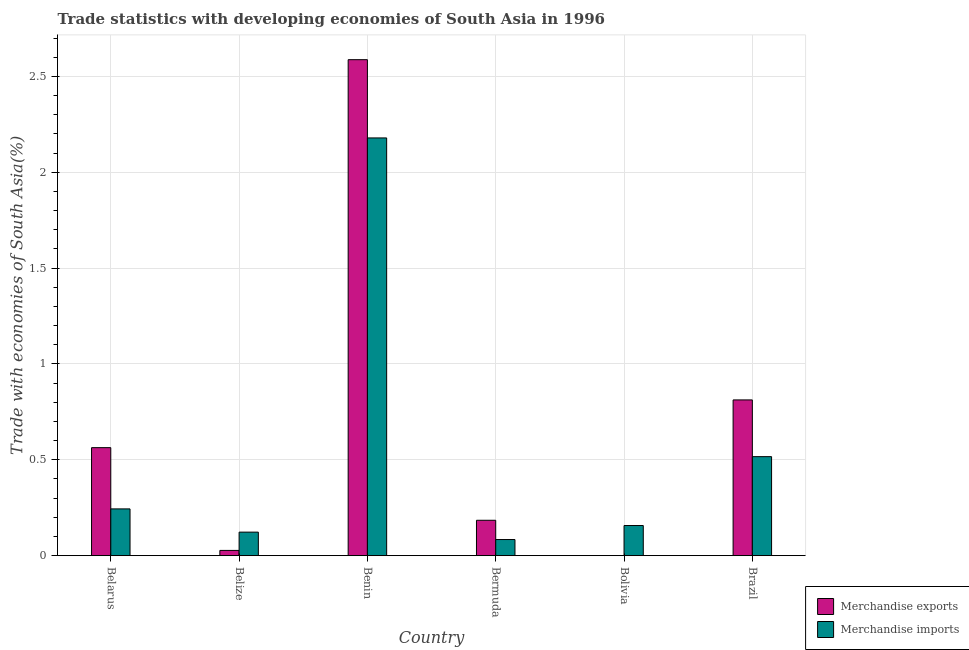How many groups of bars are there?
Your response must be concise. 6. How many bars are there on the 5th tick from the right?
Offer a terse response. 2. What is the label of the 4th group of bars from the left?
Provide a short and direct response. Bermuda. What is the merchandise exports in Bermuda?
Keep it short and to the point. 0.18. Across all countries, what is the maximum merchandise imports?
Offer a terse response. 2.18. Across all countries, what is the minimum merchandise imports?
Your response must be concise. 0.08. In which country was the merchandise exports maximum?
Ensure brevity in your answer.  Benin. In which country was the merchandise imports minimum?
Provide a succinct answer. Bermuda. What is the total merchandise imports in the graph?
Provide a succinct answer. 3.3. What is the difference between the merchandise exports in Benin and that in Brazil?
Provide a short and direct response. 1.78. What is the difference between the merchandise imports in Bolivia and the merchandise exports in Brazil?
Keep it short and to the point. -0.66. What is the average merchandise imports per country?
Make the answer very short. 0.55. What is the difference between the merchandise imports and merchandise exports in Bolivia?
Offer a terse response. 0.16. In how many countries, is the merchandise imports greater than 2.2 %?
Provide a short and direct response. 0. What is the ratio of the merchandise imports in Bermuda to that in Brazil?
Offer a very short reply. 0.16. What is the difference between the highest and the second highest merchandise imports?
Give a very brief answer. 1.66. What is the difference between the highest and the lowest merchandise imports?
Keep it short and to the point. 2.1. What does the 1st bar from the left in Belarus represents?
Your answer should be compact. Merchandise exports. What does the 2nd bar from the right in Brazil represents?
Give a very brief answer. Merchandise exports. Are all the bars in the graph horizontal?
Offer a terse response. No. How many countries are there in the graph?
Offer a terse response. 6. Does the graph contain any zero values?
Ensure brevity in your answer.  No. Where does the legend appear in the graph?
Offer a very short reply. Bottom right. What is the title of the graph?
Your answer should be very brief. Trade statistics with developing economies of South Asia in 1996. Does "Arms imports" appear as one of the legend labels in the graph?
Your answer should be very brief. No. What is the label or title of the X-axis?
Offer a terse response. Country. What is the label or title of the Y-axis?
Make the answer very short. Trade with economies of South Asia(%). What is the Trade with economies of South Asia(%) in Merchandise exports in Belarus?
Provide a succinct answer. 0.56. What is the Trade with economies of South Asia(%) in Merchandise imports in Belarus?
Provide a succinct answer. 0.24. What is the Trade with economies of South Asia(%) in Merchandise exports in Belize?
Keep it short and to the point. 0.03. What is the Trade with economies of South Asia(%) of Merchandise imports in Belize?
Your response must be concise. 0.12. What is the Trade with economies of South Asia(%) of Merchandise exports in Benin?
Provide a short and direct response. 2.59. What is the Trade with economies of South Asia(%) of Merchandise imports in Benin?
Give a very brief answer. 2.18. What is the Trade with economies of South Asia(%) of Merchandise exports in Bermuda?
Provide a short and direct response. 0.18. What is the Trade with economies of South Asia(%) in Merchandise imports in Bermuda?
Make the answer very short. 0.08. What is the Trade with economies of South Asia(%) of Merchandise exports in Bolivia?
Provide a succinct answer. 0. What is the Trade with economies of South Asia(%) in Merchandise imports in Bolivia?
Your answer should be compact. 0.16. What is the Trade with economies of South Asia(%) in Merchandise exports in Brazil?
Offer a terse response. 0.81. What is the Trade with economies of South Asia(%) in Merchandise imports in Brazil?
Offer a terse response. 0.52. Across all countries, what is the maximum Trade with economies of South Asia(%) in Merchandise exports?
Your response must be concise. 2.59. Across all countries, what is the maximum Trade with economies of South Asia(%) in Merchandise imports?
Offer a terse response. 2.18. Across all countries, what is the minimum Trade with economies of South Asia(%) of Merchandise exports?
Your answer should be very brief. 0. Across all countries, what is the minimum Trade with economies of South Asia(%) of Merchandise imports?
Ensure brevity in your answer.  0.08. What is the total Trade with economies of South Asia(%) in Merchandise exports in the graph?
Ensure brevity in your answer.  4.18. What is the total Trade with economies of South Asia(%) in Merchandise imports in the graph?
Offer a very short reply. 3.3. What is the difference between the Trade with economies of South Asia(%) in Merchandise exports in Belarus and that in Belize?
Give a very brief answer. 0.54. What is the difference between the Trade with economies of South Asia(%) of Merchandise imports in Belarus and that in Belize?
Your answer should be compact. 0.12. What is the difference between the Trade with economies of South Asia(%) of Merchandise exports in Belarus and that in Benin?
Your answer should be compact. -2.02. What is the difference between the Trade with economies of South Asia(%) of Merchandise imports in Belarus and that in Benin?
Keep it short and to the point. -1.94. What is the difference between the Trade with economies of South Asia(%) in Merchandise exports in Belarus and that in Bermuda?
Your answer should be compact. 0.38. What is the difference between the Trade with economies of South Asia(%) in Merchandise imports in Belarus and that in Bermuda?
Give a very brief answer. 0.16. What is the difference between the Trade with economies of South Asia(%) in Merchandise exports in Belarus and that in Bolivia?
Your answer should be compact. 0.56. What is the difference between the Trade with economies of South Asia(%) in Merchandise imports in Belarus and that in Bolivia?
Your answer should be compact. 0.09. What is the difference between the Trade with economies of South Asia(%) of Merchandise exports in Belarus and that in Brazil?
Ensure brevity in your answer.  -0.25. What is the difference between the Trade with economies of South Asia(%) of Merchandise imports in Belarus and that in Brazil?
Provide a succinct answer. -0.27. What is the difference between the Trade with economies of South Asia(%) of Merchandise exports in Belize and that in Benin?
Provide a short and direct response. -2.56. What is the difference between the Trade with economies of South Asia(%) in Merchandise imports in Belize and that in Benin?
Your answer should be very brief. -2.06. What is the difference between the Trade with economies of South Asia(%) of Merchandise exports in Belize and that in Bermuda?
Offer a terse response. -0.16. What is the difference between the Trade with economies of South Asia(%) in Merchandise imports in Belize and that in Bermuda?
Provide a succinct answer. 0.04. What is the difference between the Trade with economies of South Asia(%) of Merchandise exports in Belize and that in Bolivia?
Keep it short and to the point. 0.03. What is the difference between the Trade with economies of South Asia(%) of Merchandise imports in Belize and that in Bolivia?
Give a very brief answer. -0.03. What is the difference between the Trade with economies of South Asia(%) of Merchandise exports in Belize and that in Brazil?
Ensure brevity in your answer.  -0.79. What is the difference between the Trade with economies of South Asia(%) of Merchandise imports in Belize and that in Brazil?
Provide a short and direct response. -0.39. What is the difference between the Trade with economies of South Asia(%) in Merchandise exports in Benin and that in Bermuda?
Your answer should be very brief. 2.4. What is the difference between the Trade with economies of South Asia(%) in Merchandise imports in Benin and that in Bermuda?
Keep it short and to the point. 2.1. What is the difference between the Trade with economies of South Asia(%) in Merchandise exports in Benin and that in Bolivia?
Make the answer very short. 2.59. What is the difference between the Trade with economies of South Asia(%) of Merchandise imports in Benin and that in Bolivia?
Give a very brief answer. 2.02. What is the difference between the Trade with economies of South Asia(%) of Merchandise exports in Benin and that in Brazil?
Give a very brief answer. 1.78. What is the difference between the Trade with economies of South Asia(%) of Merchandise imports in Benin and that in Brazil?
Make the answer very short. 1.66. What is the difference between the Trade with economies of South Asia(%) in Merchandise exports in Bermuda and that in Bolivia?
Your response must be concise. 0.18. What is the difference between the Trade with economies of South Asia(%) in Merchandise imports in Bermuda and that in Bolivia?
Ensure brevity in your answer.  -0.07. What is the difference between the Trade with economies of South Asia(%) in Merchandise exports in Bermuda and that in Brazil?
Your answer should be compact. -0.63. What is the difference between the Trade with economies of South Asia(%) of Merchandise imports in Bermuda and that in Brazil?
Your response must be concise. -0.43. What is the difference between the Trade with economies of South Asia(%) of Merchandise exports in Bolivia and that in Brazil?
Provide a short and direct response. -0.81. What is the difference between the Trade with economies of South Asia(%) of Merchandise imports in Bolivia and that in Brazil?
Make the answer very short. -0.36. What is the difference between the Trade with economies of South Asia(%) of Merchandise exports in Belarus and the Trade with economies of South Asia(%) of Merchandise imports in Belize?
Your response must be concise. 0.44. What is the difference between the Trade with economies of South Asia(%) of Merchandise exports in Belarus and the Trade with economies of South Asia(%) of Merchandise imports in Benin?
Your response must be concise. -1.62. What is the difference between the Trade with economies of South Asia(%) of Merchandise exports in Belarus and the Trade with economies of South Asia(%) of Merchandise imports in Bermuda?
Provide a short and direct response. 0.48. What is the difference between the Trade with economies of South Asia(%) in Merchandise exports in Belarus and the Trade with economies of South Asia(%) in Merchandise imports in Bolivia?
Keep it short and to the point. 0.41. What is the difference between the Trade with economies of South Asia(%) in Merchandise exports in Belarus and the Trade with economies of South Asia(%) in Merchandise imports in Brazil?
Give a very brief answer. 0.05. What is the difference between the Trade with economies of South Asia(%) of Merchandise exports in Belize and the Trade with economies of South Asia(%) of Merchandise imports in Benin?
Give a very brief answer. -2.15. What is the difference between the Trade with economies of South Asia(%) in Merchandise exports in Belize and the Trade with economies of South Asia(%) in Merchandise imports in Bermuda?
Ensure brevity in your answer.  -0.06. What is the difference between the Trade with economies of South Asia(%) in Merchandise exports in Belize and the Trade with economies of South Asia(%) in Merchandise imports in Bolivia?
Your answer should be compact. -0.13. What is the difference between the Trade with economies of South Asia(%) in Merchandise exports in Belize and the Trade with economies of South Asia(%) in Merchandise imports in Brazil?
Offer a terse response. -0.49. What is the difference between the Trade with economies of South Asia(%) of Merchandise exports in Benin and the Trade with economies of South Asia(%) of Merchandise imports in Bermuda?
Your answer should be very brief. 2.5. What is the difference between the Trade with economies of South Asia(%) of Merchandise exports in Benin and the Trade with economies of South Asia(%) of Merchandise imports in Bolivia?
Provide a short and direct response. 2.43. What is the difference between the Trade with economies of South Asia(%) of Merchandise exports in Benin and the Trade with economies of South Asia(%) of Merchandise imports in Brazil?
Ensure brevity in your answer.  2.07. What is the difference between the Trade with economies of South Asia(%) of Merchandise exports in Bermuda and the Trade with economies of South Asia(%) of Merchandise imports in Bolivia?
Keep it short and to the point. 0.03. What is the difference between the Trade with economies of South Asia(%) in Merchandise exports in Bermuda and the Trade with economies of South Asia(%) in Merchandise imports in Brazil?
Ensure brevity in your answer.  -0.33. What is the difference between the Trade with economies of South Asia(%) in Merchandise exports in Bolivia and the Trade with economies of South Asia(%) in Merchandise imports in Brazil?
Your answer should be compact. -0.52. What is the average Trade with economies of South Asia(%) of Merchandise exports per country?
Your answer should be compact. 0.7. What is the average Trade with economies of South Asia(%) in Merchandise imports per country?
Provide a short and direct response. 0.55. What is the difference between the Trade with economies of South Asia(%) in Merchandise exports and Trade with economies of South Asia(%) in Merchandise imports in Belarus?
Your answer should be very brief. 0.32. What is the difference between the Trade with economies of South Asia(%) in Merchandise exports and Trade with economies of South Asia(%) in Merchandise imports in Belize?
Offer a terse response. -0.1. What is the difference between the Trade with economies of South Asia(%) of Merchandise exports and Trade with economies of South Asia(%) of Merchandise imports in Benin?
Provide a short and direct response. 0.41. What is the difference between the Trade with economies of South Asia(%) in Merchandise exports and Trade with economies of South Asia(%) in Merchandise imports in Bermuda?
Give a very brief answer. 0.1. What is the difference between the Trade with economies of South Asia(%) in Merchandise exports and Trade with economies of South Asia(%) in Merchandise imports in Bolivia?
Offer a very short reply. -0.16. What is the difference between the Trade with economies of South Asia(%) in Merchandise exports and Trade with economies of South Asia(%) in Merchandise imports in Brazil?
Keep it short and to the point. 0.3. What is the ratio of the Trade with economies of South Asia(%) in Merchandise exports in Belarus to that in Belize?
Offer a terse response. 20.58. What is the ratio of the Trade with economies of South Asia(%) of Merchandise imports in Belarus to that in Belize?
Offer a terse response. 1.99. What is the ratio of the Trade with economies of South Asia(%) of Merchandise exports in Belarus to that in Benin?
Your answer should be compact. 0.22. What is the ratio of the Trade with economies of South Asia(%) in Merchandise imports in Belarus to that in Benin?
Your answer should be very brief. 0.11. What is the ratio of the Trade with economies of South Asia(%) in Merchandise exports in Belarus to that in Bermuda?
Provide a short and direct response. 3.05. What is the ratio of the Trade with economies of South Asia(%) in Merchandise imports in Belarus to that in Bermuda?
Offer a very short reply. 2.9. What is the ratio of the Trade with economies of South Asia(%) of Merchandise exports in Belarus to that in Bolivia?
Keep it short and to the point. 1142.15. What is the ratio of the Trade with economies of South Asia(%) of Merchandise imports in Belarus to that in Bolivia?
Ensure brevity in your answer.  1.55. What is the ratio of the Trade with economies of South Asia(%) of Merchandise exports in Belarus to that in Brazil?
Give a very brief answer. 0.69. What is the ratio of the Trade with economies of South Asia(%) in Merchandise imports in Belarus to that in Brazil?
Keep it short and to the point. 0.47. What is the ratio of the Trade with economies of South Asia(%) of Merchandise exports in Belize to that in Benin?
Provide a short and direct response. 0.01. What is the ratio of the Trade with economies of South Asia(%) in Merchandise imports in Belize to that in Benin?
Ensure brevity in your answer.  0.06. What is the ratio of the Trade with economies of South Asia(%) of Merchandise exports in Belize to that in Bermuda?
Give a very brief answer. 0.15. What is the ratio of the Trade with economies of South Asia(%) of Merchandise imports in Belize to that in Bermuda?
Your answer should be compact. 1.46. What is the ratio of the Trade with economies of South Asia(%) of Merchandise exports in Belize to that in Bolivia?
Your answer should be compact. 55.51. What is the ratio of the Trade with economies of South Asia(%) of Merchandise imports in Belize to that in Bolivia?
Provide a succinct answer. 0.78. What is the ratio of the Trade with economies of South Asia(%) of Merchandise exports in Belize to that in Brazil?
Your answer should be compact. 0.03. What is the ratio of the Trade with economies of South Asia(%) in Merchandise imports in Belize to that in Brazil?
Offer a very short reply. 0.24. What is the ratio of the Trade with economies of South Asia(%) in Merchandise exports in Benin to that in Bermuda?
Provide a succinct answer. 14.02. What is the ratio of the Trade with economies of South Asia(%) of Merchandise imports in Benin to that in Bermuda?
Your answer should be compact. 25.93. What is the ratio of the Trade with economies of South Asia(%) in Merchandise exports in Benin to that in Bolivia?
Offer a terse response. 5244.92. What is the ratio of the Trade with economies of South Asia(%) in Merchandise imports in Benin to that in Bolivia?
Provide a succinct answer. 13.86. What is the ratio of the Trade with economies of South Asia(%) of Merchandise exports in Benin to that in Brazil?
Provide a short and direct response. 3.18. What is the ratio of the Trade with economies of South Asia(%) of Merchandise imports in Benin to that in Brazil?
Provide a short and direct response. 4.22. What is the ratio of the Trade with economies of South Asia(%) in Merchandise exports in Bermuda to that in Bolivia?
Your response must be concise. 374.1. What is the ratio of the Trade with economies of South Asia(%) of Merchandise imports in Bermuda to that in Bolivia?
Provide a succinct answer. 0.53. What is the ratio of the Trade with economies of South Asia(%) in Merchandise exports in Bermuda to that in Brazil?
Offer a very short reply. 0.23. What is the ratio of the Trade with economies of South Asia(%) in Merchandise imports in Bermuda to that in Brazil?
Your answer should be compact. 0.16. What is the ratio of the Trade with economies of South Asia(%) of Merchandise exports in Bolivia to that in Brazil?
Give a very brief answer. 0. What is the ratio of the Trade with economies of South Asia(%) of Merchandise imports in Bolivia to that in Brazil?
Your answer should be very brief. 0.3. What is the difference between the highest and the second highest Trade with economies of South Asia(%) of Merchandise exports?
Offer a very short reply. 1.78. What is the difference between the highest and the second highest Trade with economies of South Asia(%) in Merchandise imports?
Provide a short and direct response. 1.66. What is the difference between the highest and the lowest Trade with economies of South Asia(%) in Merchandise exports?
Offer a terse response. 2.59. What is the difference between the highest and the lowest Trade with economies of South Asia(%) in Merchandise imports?
Your answer should be compact. 2.1. 